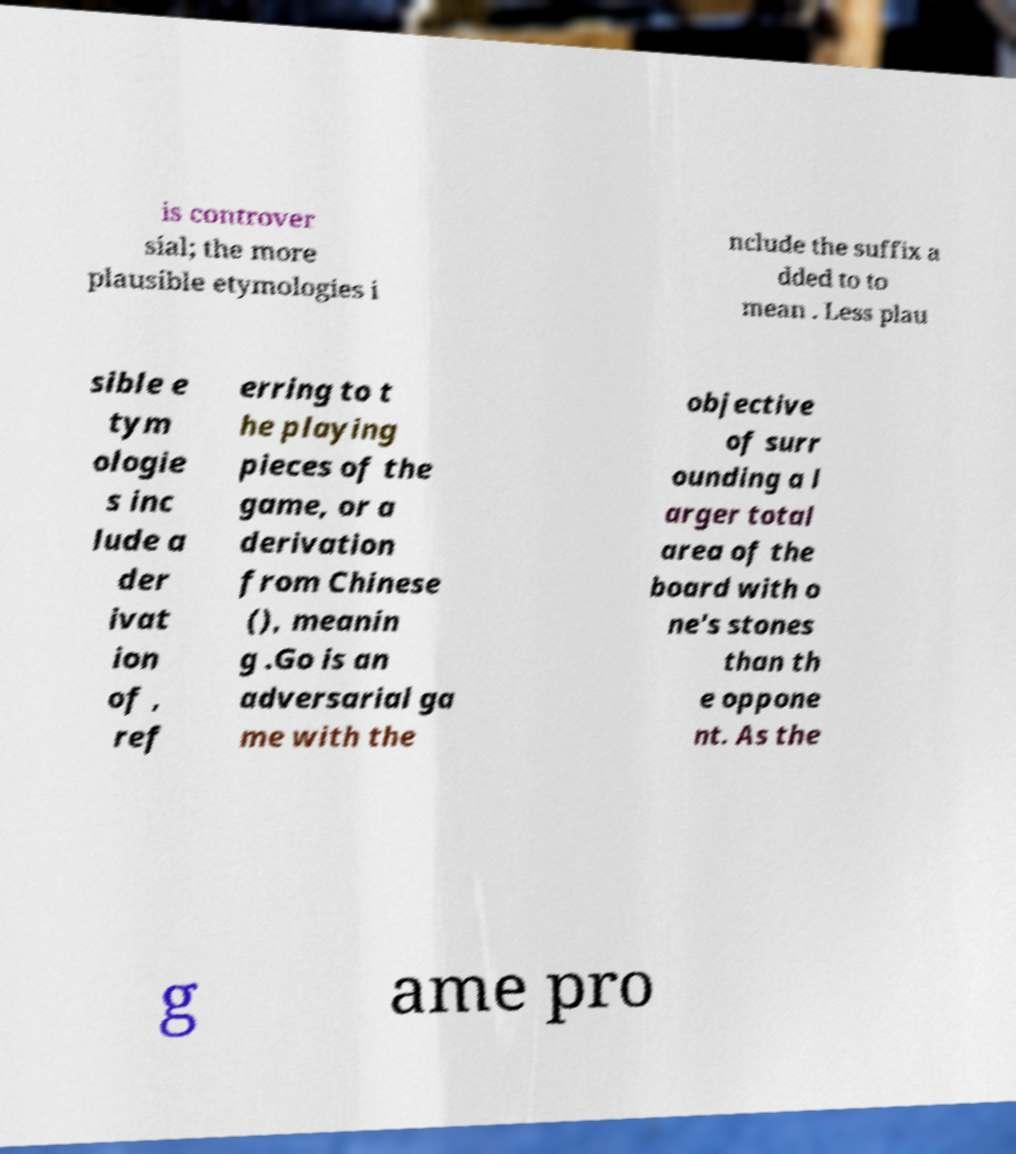For documentation purposes, I need the text within this image transcribed. Could you provide that? is controver sial; the more plausible etymologies i nclude the suffix a dded to to mean . Less plau sible e tym ologie s inc lude a der ivat ion of , ref erring to t he playing pieces of the game, or a derivation from Chinese (), meanin g .Go is an adversarial ga me with the objective of surr ounding a l arger total area of the board with o ne's stones than th e oppone nt. As the g ame pro 